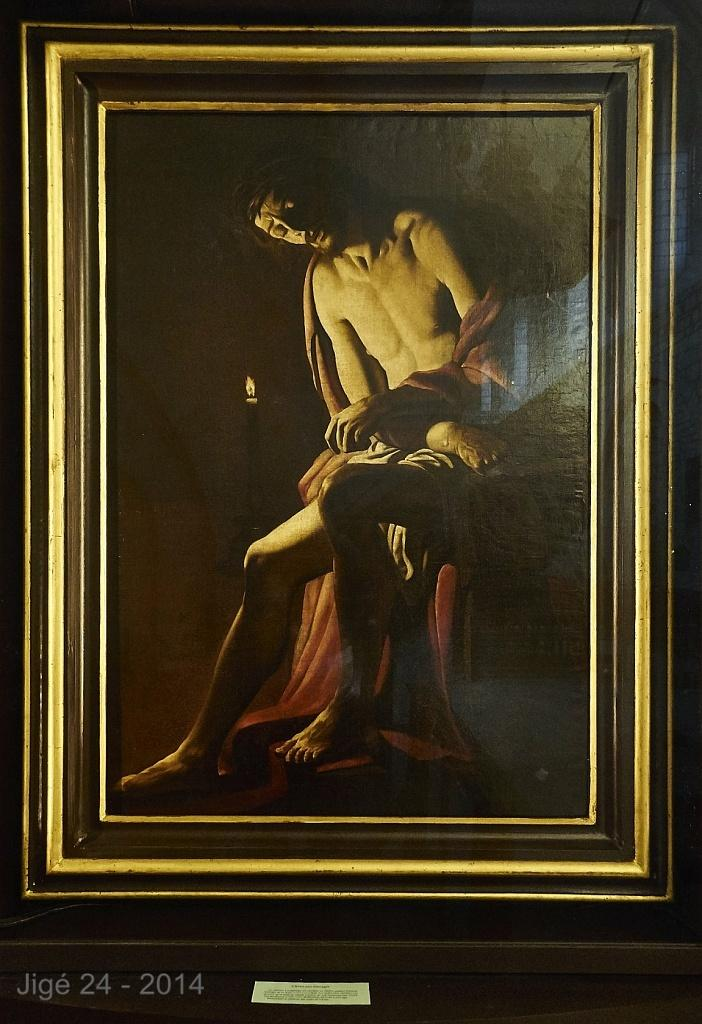<image>
Provide a brief description of the given image. A painting of a man labeled Jige 24 - 2014. 